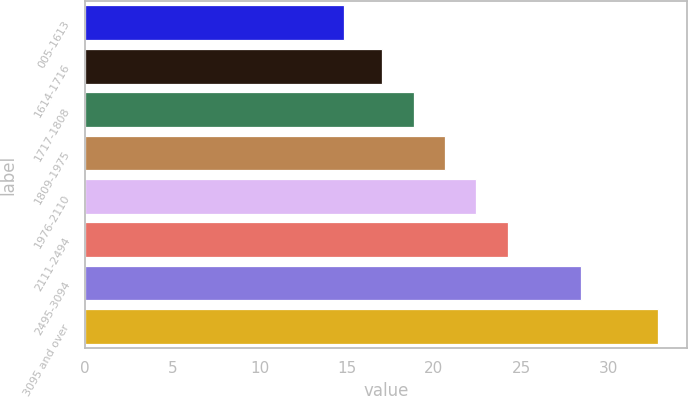<chart> <loc_0><loc_0><loc_500><loc_500><bar_chart><fcel>005-1613<fcel>1614-1716<fcel>1717-1808<fcel>1809-1975<fcel>1976-2110<fcel>2111-2494<fcel>2495-3094<fcel>3095 and over<nl><fcel>14.84<fcel>17.03<fcel>18.83<fcel>20.63<fcel>22.43<fcel>24.23<fcel>28.42<fcel>32.86<nl></chart> 